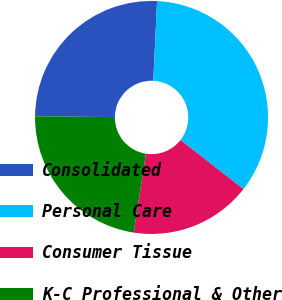Convert chart. <chart><loc_0><loc_0><loc_500><loc_500><pie_chart><fcel>Consolidated<fcel>Personal Care<fcel>Consumer Tissue<fcel>K-C Professional & Other<nl><fcel>25.6%<fcel>34.78%<fcel>16.91%<fcel>22.71%<nl></chart> 